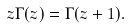<formula> <loc_0><loc_0><loc_500><loc_500>z \Gamma ( z ) = \Gamma ( z + 1 ) .</formula> 